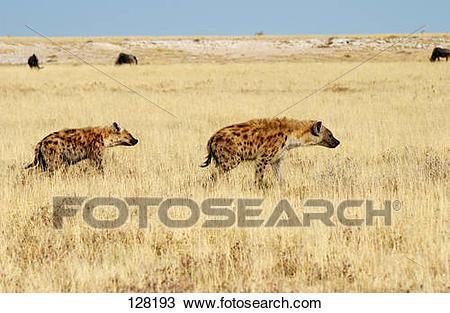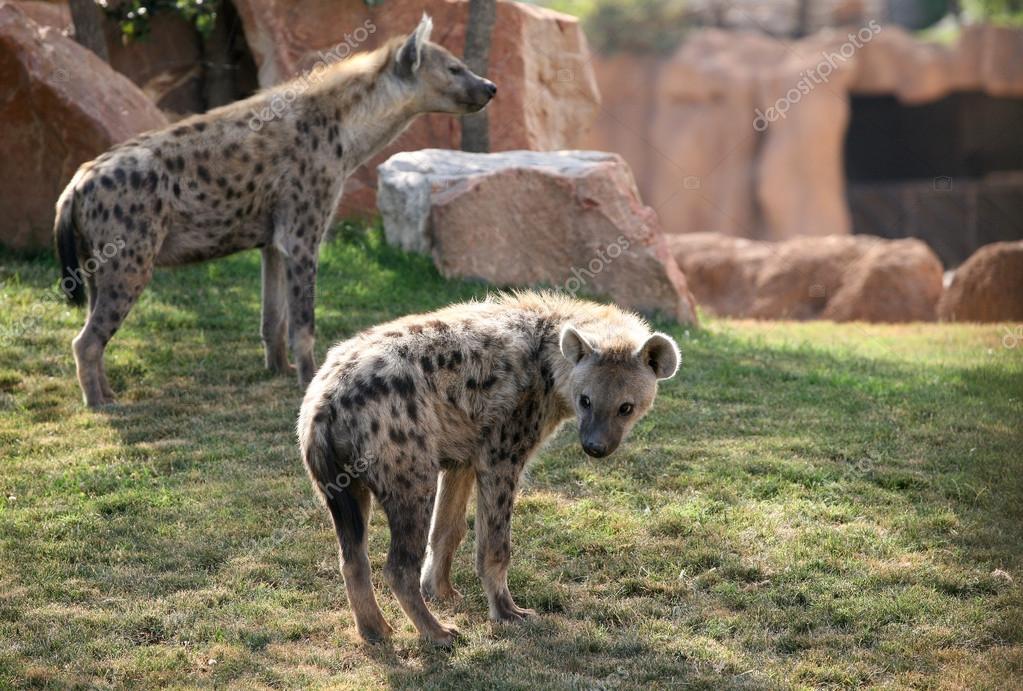The first image is the image on the left, the second image is the image on the right. Analyze the images presented: Is the assertion "An image shows two hyenas posed nose to nose, with no carcass between them." valid? Answer yes or no. No. The first image is the image on the left, the second image is the image on the right. Evaluate the accuracy of this statement regarding the images: "One animal is lying down and another is standing in at least one of the images.". Is it true? Answer yes or no. No. 